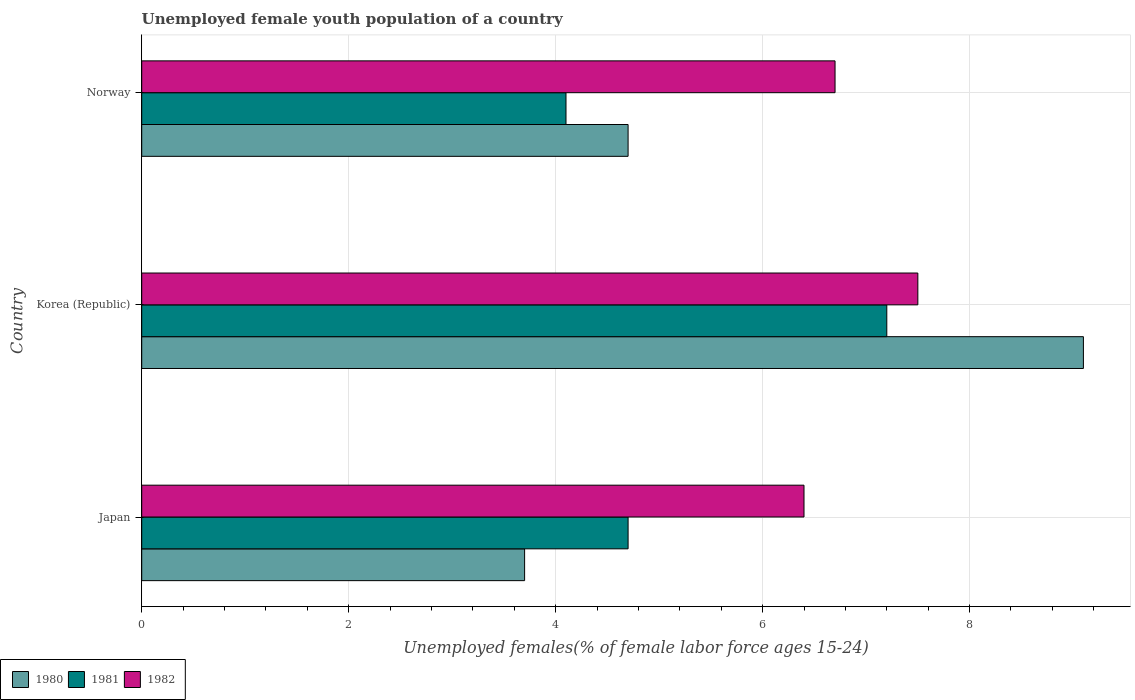How many different coloured bars are there?
Provide a short and direct response. 3. How many groups of bars are there?
Provide a short and direct response. 3. Are the number of bars per tick equal to the number of legend labels?
Ensure brevity in your answer.  Yes. Are the number of bars on each tick of the Y-axis equal?
Give a very brief answer. Yes. How many bars are there on the 1st tick from the top?
Keep it short and to the point. 3. How many bars are there on the 1st tick from the bottom?
Offer a very short reply. 3. What is the label of the 3rd group of bars from the top?
Provide a short and direct response. Japan. What is the percentage of unemployed female youth population in 1980 in Norway?
Offer a very short reply. 4.7. Across all countries, what is the maximum percentage of unemployed female youth population in 1981?
Your answer should be very brief. 7.2. Across all countries, what is the minimum percentage of unemployed female youth population in 1980?
Your answer should be very brief. 3.7. In which country was the percentage of unemployed female youth population in 1981 minimum?
Your answer should be very brief. Norway. What is the total percentage of unemployed female youth population in 1981 in the graph?
Ensure brevity in your answer.  16. What is the difference between the percentage of unemployed female youth population in 1982 in Japan and that in Korea (Republic)?
Your answer should be compact. -1.1. What is the difference between the percentage of unemployed female youth population in 1981 in Japan and the percentage of unemployed female youth population in 1980 in Norway?
Make the answer very short. 0. What is the average percentage of unemployed female youth population in 1981 per country?
Your answer should be very brief. 5.33. What is the difference between the percentage of unemployed female youth population in 1981 and percentage of unemployed female youth population in 1980 in Norway?
Your answer should be compact. -0.6. What is the ratio of the percentage of unemployed female youth population in 1981 in Japan to that in Norway?
Offer a terse response. 1.15. Is the percentage of unemployed female youth population in 1982 in Japan less than that in Korea (Republic)?
Give a very brief answer. Yes. What is the difference between the highest and the second highest percentage of unemployed female youth population in 1980?
Your answer should be compact. 4.4. What is the difference between the highest and the lowest percentage of unemployed female youth population in 1982?
Your answer should be very brief. 1.1. In how many countries, is the percentage of unemployed female youth population in 1982 greater than the average percentage of unemployed female youth population in 1982 taken over all countries?
Keep it short and to the point. 1. Is the sum of the percentage of unemployed female youth population in 1981 in Korea (Republic) and Norway greater than the maximum percentage of unemployed female youth population in 1982 across all countries?
Your answer should be compact. Yes. What does the 1st bar from the bottom in Korea (Republic) represents?
Keep it short and to the point. 1980. How many bars are there?
Provide a short and direct response. 9. Are all the bars in the graph horizontal?
Ensure brevity in your answer.  Yes. How many countries are there in the graph?
Your answer should be compact. 3. What is the difference between two consecutive major ticks on the X-axis?
Give a very brief answer. 2. Are the values on the major ticks of X-axis written in scientific E-notation?
Your response must be concise. No. Does the graph contain any zero values?
Keep it short and to the point. No. Does the graph contain grids?
Your answer should be very brief. Yes. Where does the legend appear in the graph?
Ensure brevity in your answer.  Bottom left. How are the legend labels stacked?
Provide a succinct answer. Horizontal. What is the title of the graph?
Provide a succinct answer. Unemployed female youth population of a country. Does "1981" appear as one of the legend labels in the graph?
Provide a short and direct response. Yes. What is the label or title of the X-axis?
Provide a succinct answer. Unemployed females(% of female labor force ages 15-24). What is the label or title of the Y-axis?
Offer a terse response. Country. What is the Unemployed females(% of female labor force ages 15-24) of 1980 in Japan?
Keep it short and to the point. 3.7. What is the Unemployed females(% of female labor force ages 15-24) of 1981 in Japan?
Ensure brevity in your answer.  4.7. What is the Unemployed females(% of female labor force ages 15-24) of 1982 in Japan?
Provide a short and direct response. 6.4. What is the Unemployed females(% of female labor force ages 15-24) in 1980 in Korea (Republic)?
Provide a short and direct response. 9.1. What is the Unemployed females(% of female labor force ages 15-24) of 1981 in Korea (Republic)?
Provide a succinct answer. 7.2. What is the Unemployed females(% of female labor force ages 15-24) in 1980 in Norway?
Offer a terse response. 4.7. What is the Unemployed females(% of female labor force ages 15-24) in 1981 in Norway?
Your response must be concise. 4.1. What is the Unemployed females(% of female labor force ages 15-24) in 1982 in Norway?
Your response must be concise. 6.7. Across all countries, what is the maximum Unemployed females(% of female labor force ages 15-24) in 1980?
Ensure brevity in your answer.  9.1. Across all countries, what is the maximum Unemployed females(% of female labor force ages 15-24) in 1981?
Give a very brief answer. 7.2. Across all countries, what is the minimum Unemployed females(% of female labor force ages 15-24) in 1980?
Offer a very short reply. 3.7. Across all countries, what is the minimum Unemployed females(% of female labor force ages 15-24) of 1981?
Give a very brief answer. 4.1. Across all countries, what is the minimum Unemployed females(% of female labor force ages 15-24) in 1982?
Your answer should be compact. 6.4. What is the total Unemployed females(% of female labor force ages 15-24) of 1982 in the graph?
Your answer should be compact. 20.6. What is the difference between the Unemployed females(% of female labor force ages 15-24) of 1980 in Japan and that in Korea (Republic)?
Your response must be concise. -5.4. What is the difference between the Unemployed females(% of female labor force ages 15-24) in 1981 in Japan and that in Korea (Republic)?
Keep it short and to the point. -2.5. What is the difference between the Unemployed females(% of female labor force ages 15-24) of 1982 in Japan and that in Korea (Republic)?
Provide a succinct answer. -1.1. What is the difference between the Unemployed females(% of female labor force ages 15-24) of 1980 in Japan and that in Norway?
Offer a terse response. -1. What is the difference between the Unemployed females(% of female labor force ages 15-24) in 1981 in Japan and that in Norway?
Your answer should be very brief. 0.6. What is the difference between the Unemployed females(% of female labor force ages 15-24) of 1982 in Japan and that in Norway?
Provide a succinct answer. -0.3. What is the difference between the Unemployed females(% of female labor force ages 15-24) of 1982 in Korea (Republic) and that in Norway?
Make the answer very short. 0.8. What is the difference between the Unemployed females(% of female labor force ages 15-24) of 1980 in Japan and the Unemployed females(% of female labor force ages 15-24) of 1981 in Korea (Republic)?
Offer a terse response. -3.5. What is the difference between the Unemployed females(% of female labor force ages 15-24) in 1980 in Japan and the Unemployed females(% of female labor force ages 15-24) in 1982 in Korea (Republic)?
Your answer should be compact. -3.8. What is the difference between the Unemployed females(% of female labor force ages 15-24) of 1980 in Japan and the Unemployed females(% of female labor force ages 15-24) of 1982 in Norway?
Make the answer very short. -3. What is the difference between the Unemployed females(% of female labor force ages 15-24) of 1981 in Korea (Republic) and the Unemployed females(% of female labor force ages 15-24) of 1982 in Norway?
Your response must be concise. 0.5. What is the average Unemployed females(% of female labor force ages 15-24) of 1980 per country?
Provide a succinct answer. 5.83. What is the average Unemployed females(% of female labor force ages 15-24) in 1981 per country?
Make the answer very short. 5.33. What is the average Unemployed females(% of female labor force ages 15-24) of 1982 per country?
Make the answer very short. 6.87. What is the difference between the Unemployed females(% of female labor force ages 15-24) of 1980 and Unemployed females(% of female labor force ages 15-24) of 1981 in Japan?
Make the answer very short. -1. What is the difference between the Unemployed females(% of female labor force ages 15-24) in 1980 and Unemployed females(% of female labor force ages 15-24) in 1982 in Japan?
Give a very brief answer. -2.7. What is the difference between the Unemployed females(% of female labor force ages 15-24) in 1981 and Unemployed females(% of female labor force ages 15-24) in 1982 in Japan?
Offer a terse response. -1.7. What is the difference between the Unemployed females(% of female labor force ages 15-24) of 1981 and Unemployed females(% of female labor force ages 15-24) of 1982 in Korea (Republic)?
Offer a terse response. -0.3. What is the difference between the Unemployed females(% of female labor force ages 15-24) in 1980 and Unemployed females(% of female labor force ages 15-24) in 1981 in Norway?
Provide a short and direct response. 0.6. What is the ratio of the Unemployed females(% of female labor force ages 15-24) of 1980 in Japan to that in Korea (Republic)?
Your response must be concise. 0.41. What is the ratio of the Unemployed females(% of female labor force ages 15-24) in 1981 in Japan to that in Korea (Republic)?
Make the answer very short. 0.65. What is the ratio of the Unemployed females(% of female labor force ages 15-24) of 1982 in Japan to that in Korea (Republic)?
Offer a very short reply. 0.85. What is the ratio of the Unemployed females(% of female labor force ages 15-24) in 1980 in Japan to that in Norway?
Your answer should be very brief. 0.79. What is the ratio of the Unemployed females(% of female labor force ages 15-24) in 1981 in Japan to that in Norway?
Offer a very short reply. 1.15. What is the ratio of the Unemployed females(% of female labor force ages 15-24) of 1982 in Japan to that in Norway?
Offer a very short reply. 0.96. What is the ratio of the Unemployed females(% of female labor force ages 15-24) in 1980 in Korea (Republic) to that in Norway?
Provide a succinct answer. 1.94. What is the ratio of the Unemployed females(% of female labor force ages 15-24) in 1981 in Korea (Republic) to that in Norway?
Your answer should be compact. 1.76. What is the ratio of the Unemployed females(% of female labor force ages 15-24) of 1982 in Korea (Republic) to that in Norway?
Provide a short and direct response. 1.12. What is the difference between the highest and the second highest Unemployed females(% of female labor force ages 15-24) in 1980?
Give a very brief answer. 4.4. What is the difference between the highest and the second highest Unemployed females(% of female labor force ages 15-24) in 1981?
Give a very brief answer. 2.5. What is the difference between the highest and the second highest Unemployed females(% of female labor force ages 15-24) of 1982?
Make the answer very short. 0.8. What is the difference between the highest and the lowest Unemployed females(% of female labor force ages 15-24) of 1980?
Provide a succinct answer. 5.4. What is the difference between the highest and the lowest Unemployed females(% of female labor force ages 15-24) of 1981?
Offer a terse response. 3.1. What is the difference between the highest and the lowest Unemployed females(% of female labor force ages 15-24) in 1982?
Your answer should be compact. 1.1. 